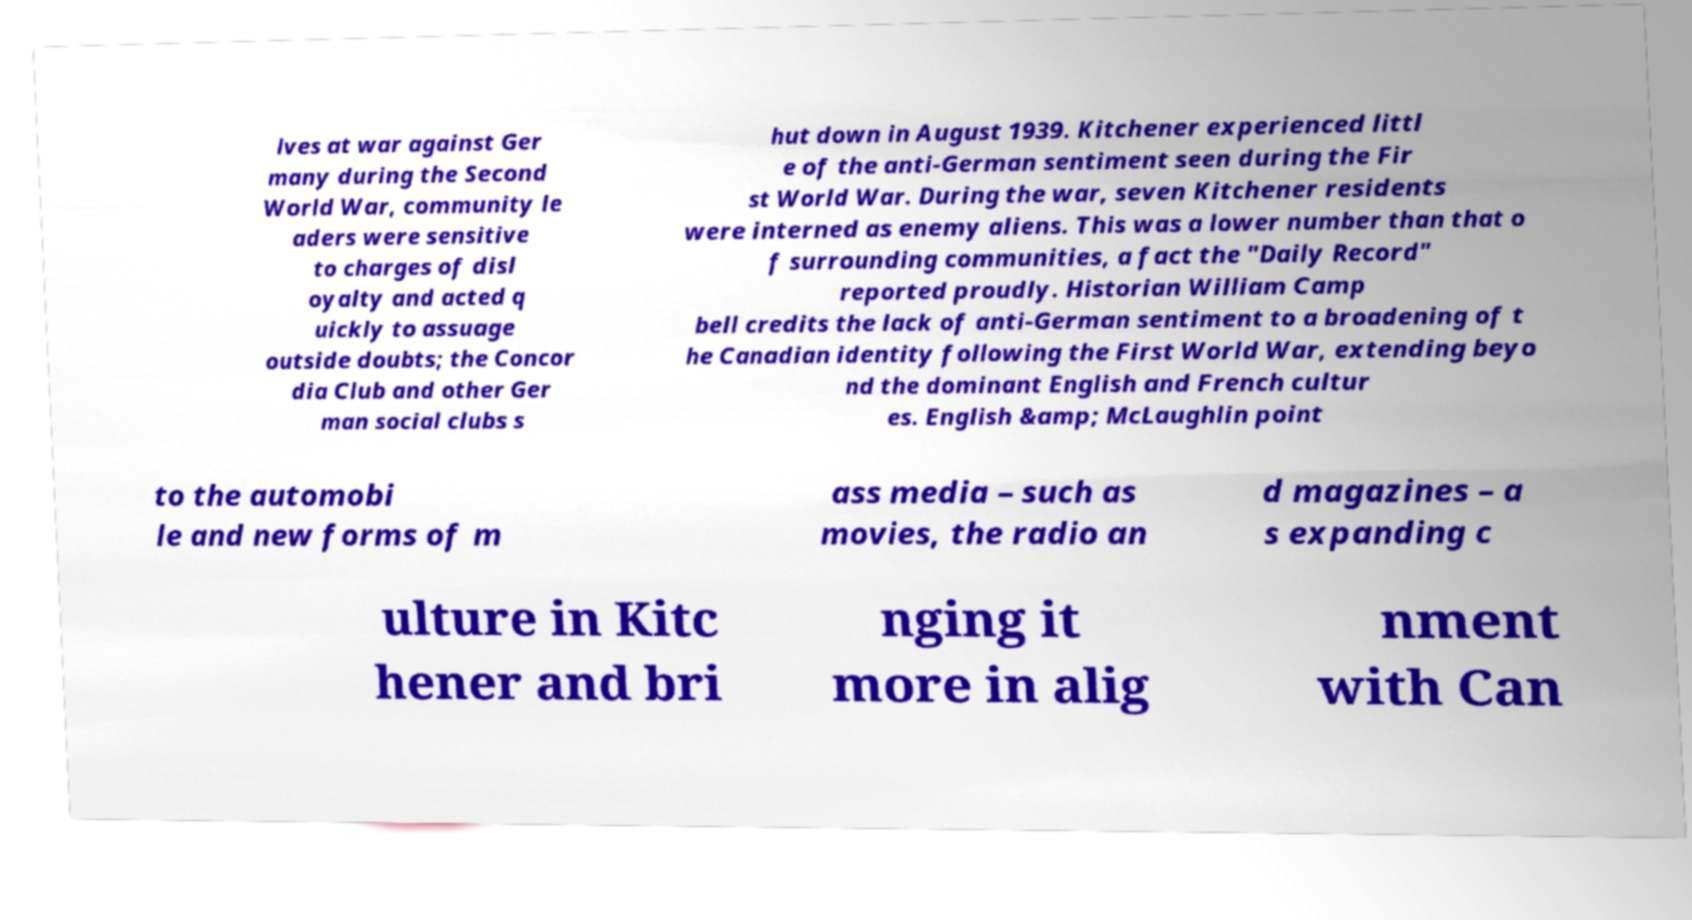What messages or text are displayed in this image? I need them in a readable, typed format. lves at war against Ger many during the Second World War, community le aders were sensitive to charges of disl oyalty and acted q uickly to assuage outside doubts; the Concor dia Club and other Ger man social clubs s hut down in August 1939. Kitchener experienced littl e of the anti-German sentiment seen during the Fir st World War. During the war, seven Kitchener residents were interned as enemy aliens. This was a lower number than that o f surrounding communities, a fact the "Daily Record" reported proudly. Historian William Camp bell credits the lack of anti-German sentiment to a broadening of t he Canadian identity following the First World War, extending beyo nd the dominant English and French cultur es. English &amp; McLaughlin point to the automobi le and new forms of m ass media – such as movies, the radio an d magazines – a s expanding c ulture in Kitc hener and bri nging it more in alig nment with Can 